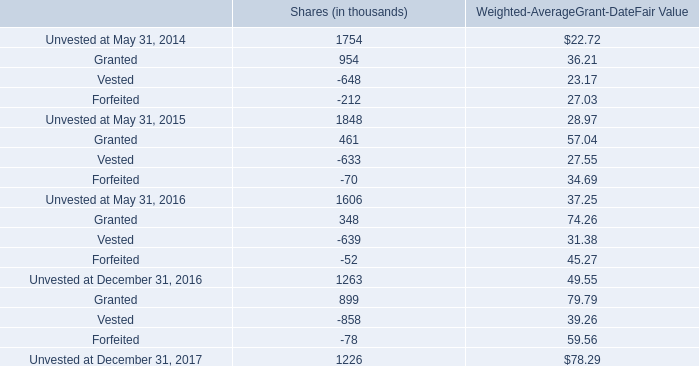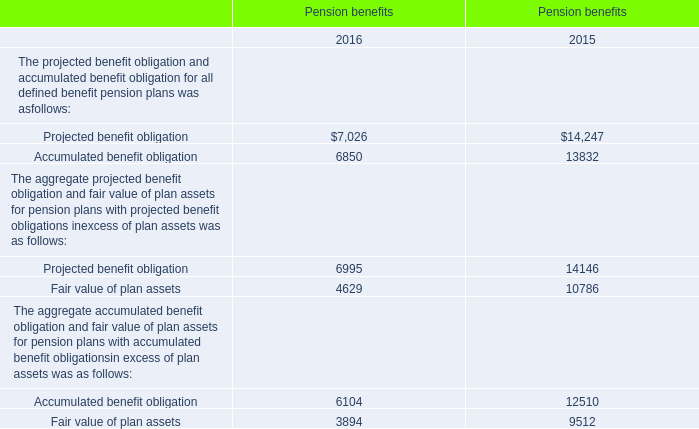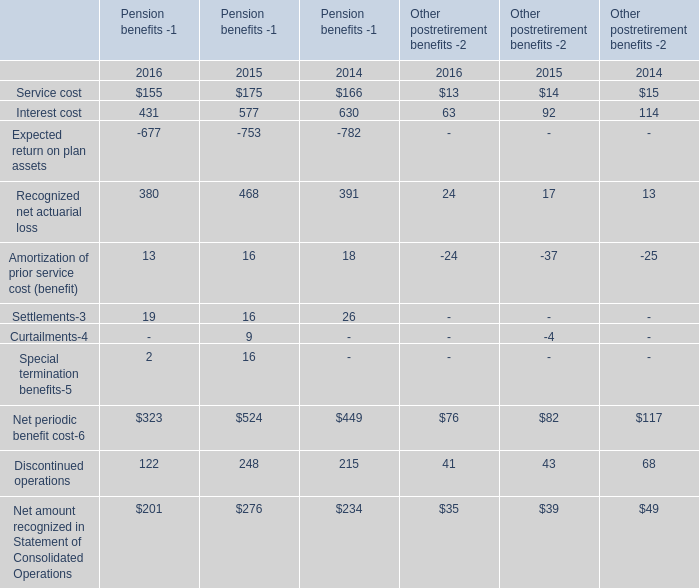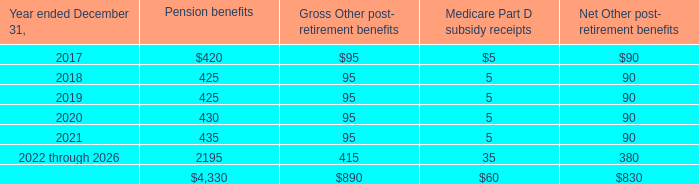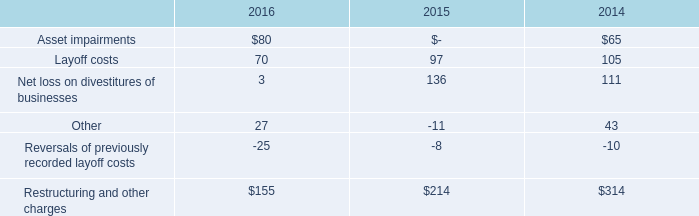Which year is Pension benefits of The projected benefit obligation and accumulated benefit obligation for all defined benefit pension plans greater than 27000? 
Answer: 2015. 